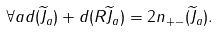<formula> <loc_0><loc_0><loc_500><loc_500>\forall a d ( { \widetilde { J } } _ { a } ) + d ( R { \widetilde { J } } _ { a } ) = 2 n _ { + - } ( { \widetilde { J } } _ { a } ) .</formula> 